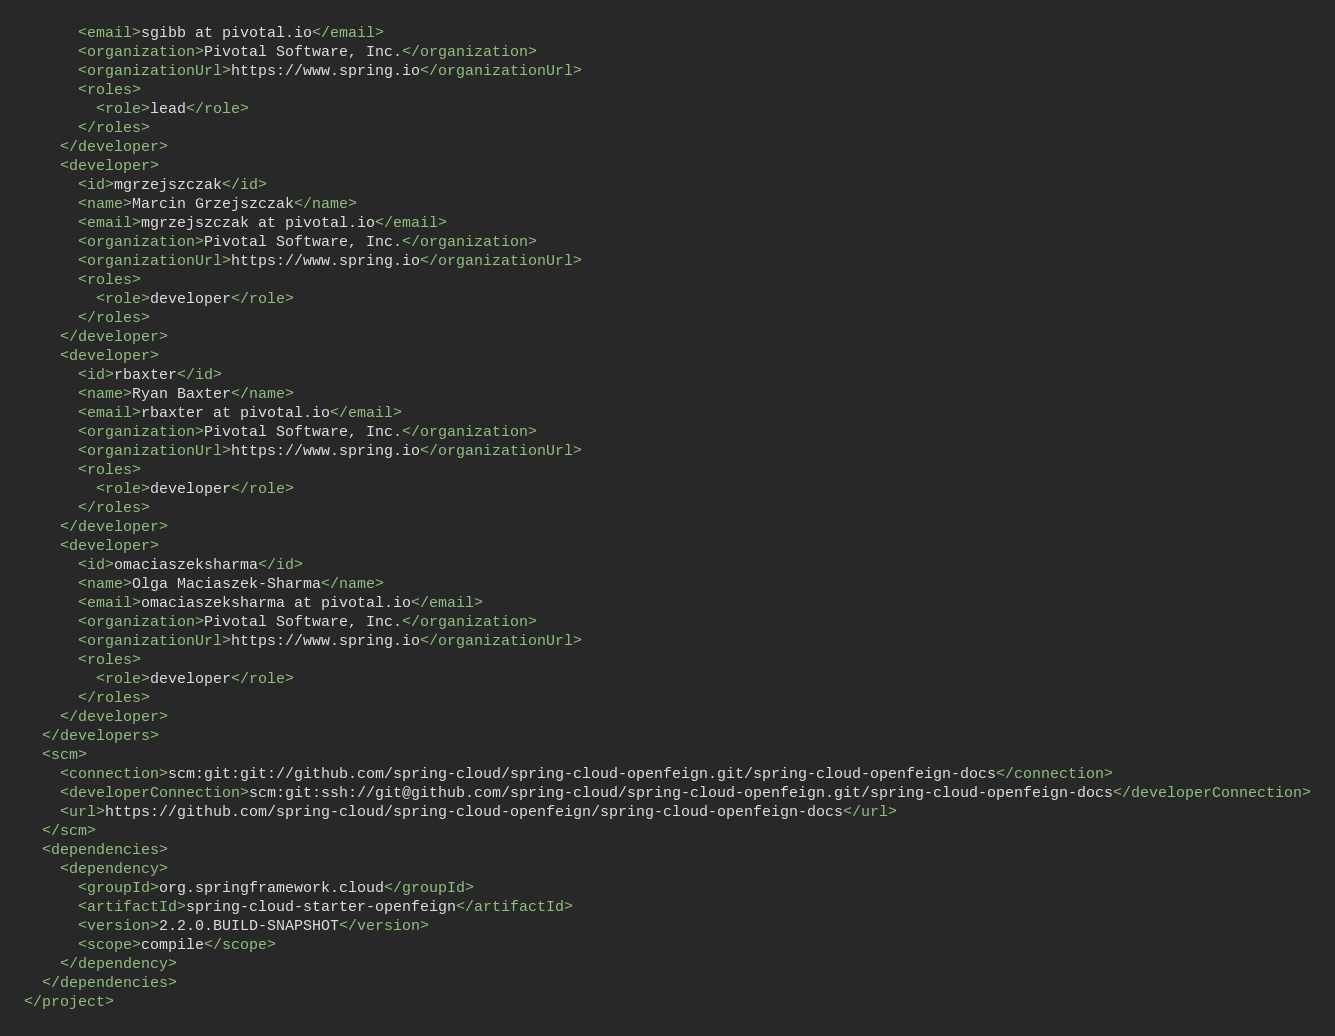<code> <loc_0><loc_0><loc_500><loc_500><_XML_>      <email>sgibb at pivotal.io</email>
      <organization>Pivotal Software, Inc.</organization>
      <organizationUrl>https://www.spring.io</organizationUrl>
      <roles>
        <role>lead</role>
      </roles>
    </developer>
    <developer>
      <id>mgrzejszczak</id>
      <name>Marcin Grzejszczak</name>
      <email>mgrzejszczak at pivotal.io</email>
      <organization>Pivotal Software, Inc.</organization>
      <organizationUrl>https://www.spring.io</organizationUrl>
      <roles>
        <role>developer</role>
      </roles>
    </developer>
    <developer>
      <id>rbaxter</id>
      <name>Ryan Baxter</name>
      <email>rbaxter at pivotal.io</email>
      <organization>Pivotal Software, Inc.</organization>
      <organizationUrl>https://www.spring.io</organizationUrl>
      <roles>
        <role>developer</role>
      </roles>
    </developer>
    <developer>
      <id>omaciaszeksharma</id>
      <name>Olga Maciaszek-Sharma</name>
      <email>omaciaszeksharma at pivotal.io</email>
      <organization>Pivotal Software, Inc.</organization>
      <organizationUrl>https://www.spring.io</organizationUrl>
      <roles>
        <role>developer</role>
      </roles>
    </developer>
  </developers>
  <scm>
    <connection>scm:git:git://github.com/spring-cloud/spring-cloud-openfeign.git/spring-cloud-openfeign-docs</connection>
    <developerConnection>scm:git:ssh://git@github.com/spring-cloud/spring-cloud-openfeign.git/spring-cloud-openfeign-docs</developerConnection>
    <url>https://github.com/spring-cloud/spring-cloud-openfeign/spring-cloud-openfeign-docs</url>
  </scm>
  <dependencies>
    <dependency>
      <groupId>org.springframework.cloud</groupId>
      <artifactId>spring-cloud-starter-openfeign</artifactId>
      <version>2.2.0.BUILD-SNAPSHOT</version>
      <scope>compile</scope>
    </dependency>
  </dependencies>
</project>
</code> 